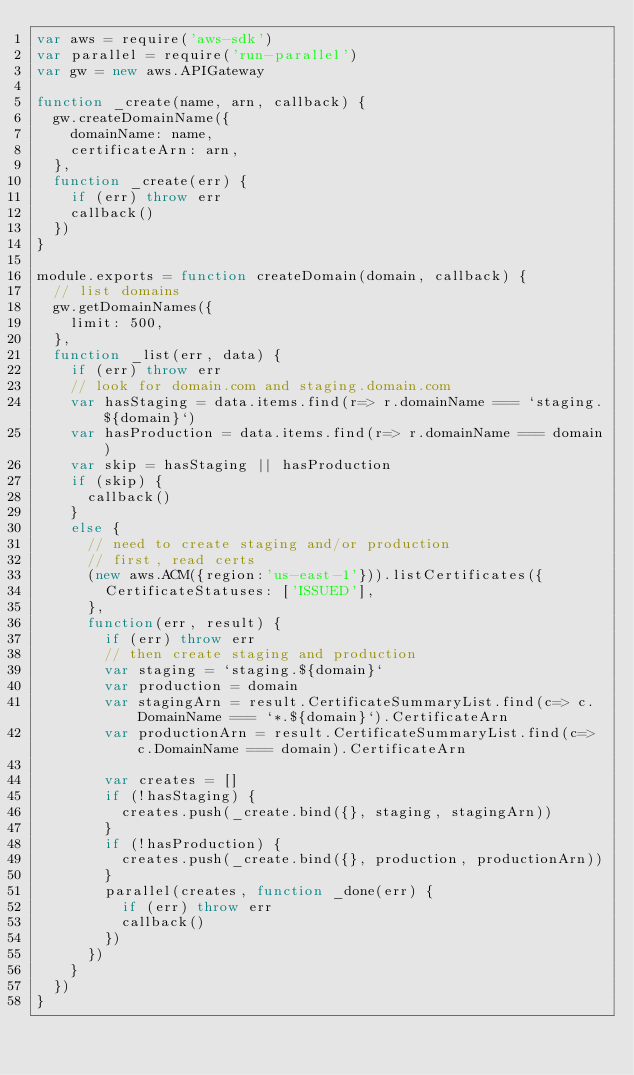<code> <loc_0><loc_0><loc_500><loc_500><_JavaScript_>var aws = require('aws-sdk')
var parallel = require('run-parallel')
var gw = new aws.APIGateway

function _create(name, arn, callback) {
  gw.createDomainName({
    domainName: name,
    certificateArn: arn,
  },
  function _create(err) {
    if (err) throw err
    callback()
  })
}

module.exports = function createDomain(domain, callback) {
  // list domains
  gw.getDomainNames({
    limit: 500,
  },
  function _list(err, data) {
    if (err) throw err
    // look for domain.com and staging.domain.com
    var hasStaging = data.items.find(r=> r.domainName === `staging.${domain}`)
    var hasProduction = data.items.find(r=> r.domainName === domain)
    var skip = hasStaging || hasProduction
    if (skip) {
      callback()
    }
    else {
      // need to create staging and/or production
      // first, read certs
      (new aws.ACM({region:'us-east-1'})).listCertificates({
        CertificateStatuses: ['ISSUED'],
      },
      function(err, result) {
        if (err) throw err
        // then create staging and production
        var staging = `staging.${domain}`
        var production = domain
        var stagingArn = result.CertificateSummaryList.find(c=> c.DomainName === `*.${domain}`).CertificateArn
        var productionArn = result.CertificateSummaryList.find(c=> c.DomainName === domain).CertificateArn

        var creates = []
        if (!hasStaging) {
          creates.push(_create.bind({}, staging, stagingArn))
        }
        if (!hasProduction) {
          creates.push(_create.bind({}, production, productionArn))
        }
        parallel(creates, function _done(err) {
          if (err) throw err
          callback()
        })
      })
    }
  })
}

</code> 